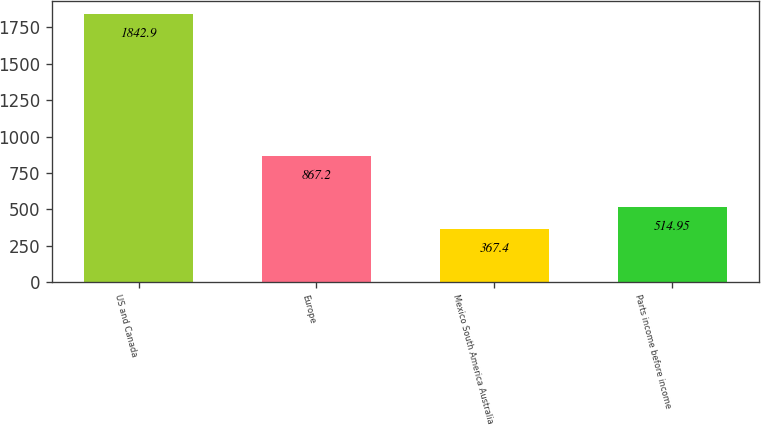Convert chart. <chart><loc_0><loc_0><loc_500><loc_500><bar_chart><fcel>US and Canada<fcel>Europe<fcel>Mexico South America Australia<fcel>Parts income before income<nl><fcel>1842.9<fcel>867.2<fcel>367.4<fcel>514.95<nl></chart> 